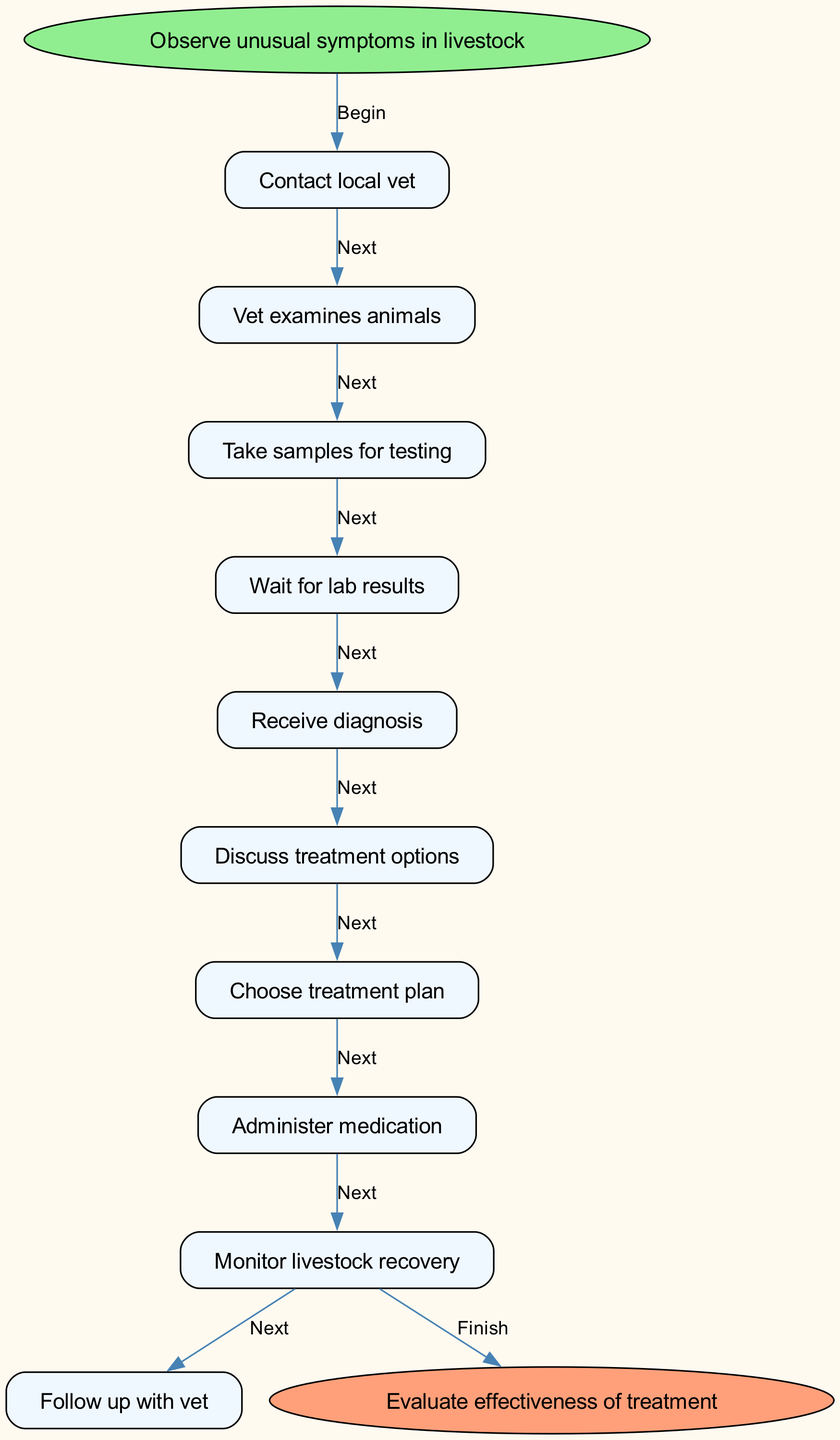What is the first step in the diagram? The first step indicated in the diagram is to "Observe unusual symptoms in livestock." This is explicitly labeled as the starting point of the flowchart before any other steps take place.
Answer: Observe unusual symptoms in livestock How many steps are there in total? By counting the steps listed in the flowchart, there are a total of nine steps from the start to the point right before receiving the diagnosis. This is determined by carefully reviewing the sequence of actions outlined.
Answer: Nine steps What is the node after "Choose treatment plan"? According to the flowchart, the next node after "Choose treatment plan" is "Administer medication." This follows logically as a continuation of the process after deciding on the treatment.
Answer: Administer medication What is the final step in the process? The last step in the flowchart is "Evaluate effectiveness of treatment." This is clearly stated as the endpoint after monitoring the livestock recovery and following up with the vet.
Answer: Evaluate effectiveness of treatment What action directly follows "Wait for lab results"? The action that directly follows "Wait for lab results" is "Receive diagnosis." This connection shows the progression after the waiting period, which is indicated in the flow.
Answer: Receive diagnosis What connection exists between "Discuss treatment options" and "Choose treatment plan"? The connection between "Discuss treatment options" and "Choose treatment plan" is that "Choose treatment plan" is the next step directly after discussing the various treatment options available, showing a decision-making flow.
Answer: The next step How many steps are between the start and receiving the diagnosis? There are four steps between the start and receiving the diagnosis. Starting from "Vet examines animals" to "Take samples for testing," followed by "Wait for lab results," and then finally "Receive diagnosis." Each step directly contributes to the process leading up to the diagnosis.
Answer: Four steps What is the purpose of "Monitor livestock recovery"? The purpose of "Monitor livestock recovery" is to ensure that the livestock is responding positively to the administered treatment and to identify any further needs for care or adjustments in the treatment plan. This monitoring is essential to assess the effectiveness of the chosen treatment.
Answer: To ensure recovery Which step comes after "Administer medication"? The step that comes after "Administer medication" is "Monitor livestock recovery." This indicates that once medication is given, the next logical action is to observe the animals' recovery progress.
Answer: Monitor livestock recovery 